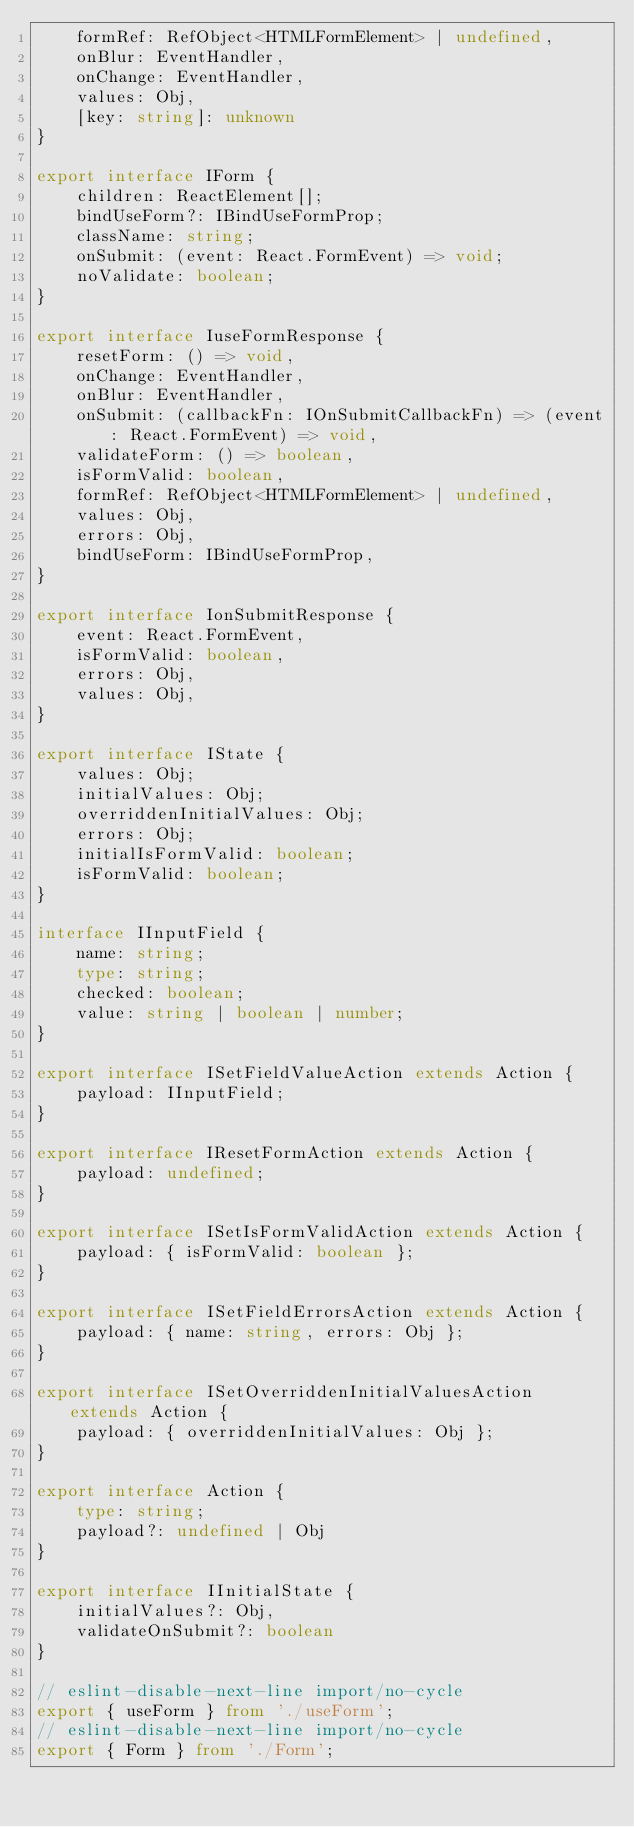<code> <loc_0><loc_0><loc_500><loc_500><_TypeScript_>    formRef: RefObject<HTMLFormElement> | undefined,
    onBlur: EventHandler,
    onChange: EventHandler,
    values: Obj,
    [key: string]: unknown
}

export interface IForm {
    children: ReactElement[];
    bindUseForm?: IBindUseFormProp;
    className: string;
    onSubmit: (event: React.FormEvent) => void;
    noValidate: boolean;
}

export interface IuseFormResponse {
    resetForm: () => void,
    onChange: EventHandler,
    onBlur: EventHandler,
    onSubmit: (callbackFn: IOnSubmitCallbackFn) => (event: React.FormEvent) => void,
    validateForm: () => boolean,
    isFormValid: boolean,
    formRef: RefObject<HTMLFormElement> | undefined,
    values: Obj,
    errors: Obj,
    bindUseForm: IBindUseFormProp,
}

export interface IonSubmitResponse {
    event: React.FormEvent,
    isFormValid: boolean,
    errors: Obj,
    values: Obj,
}

export interface IState {
    values: Obj;
    initialValues: Obj;
    overriddenInitialValues: Obj;
    errors: Obj;
    initialIsFormValid: boolean;
    isFormValid: boolean;
}

interface IInputField {
    name: string;
    type: string;
    checked: boolean;
    value: string | boolean | number;
}

export interface ISetFieldValueAction extends Action {
    payload: IInputField;
}

export interface IResetFormAction extends Action {
    payload: undefined;
}

export interface ISetIsFormValidAction extends Action {
    payload: { isFormValid: boolean };
}

export interface ISetFieldErrorsAction extends Action {
    payload: { name: string, errors: Obj };
}

export interface ISetOverriddenInitialValuesAction extends Action {
    payload: { overriddenInitialValues: Obj };
}

export interface Action {
    type: string;
    payload?: undefined | Obj
}

export interface IInitialState {
    initialValues?: Obj,
    validateOnSubmit?: boolean
}

// eslint-disable-next-line import/no-cycle
export { useForm } from './useForm';
// eslint-disable-next-line import/no-cycle
export { Form } from './Form';
</code> 